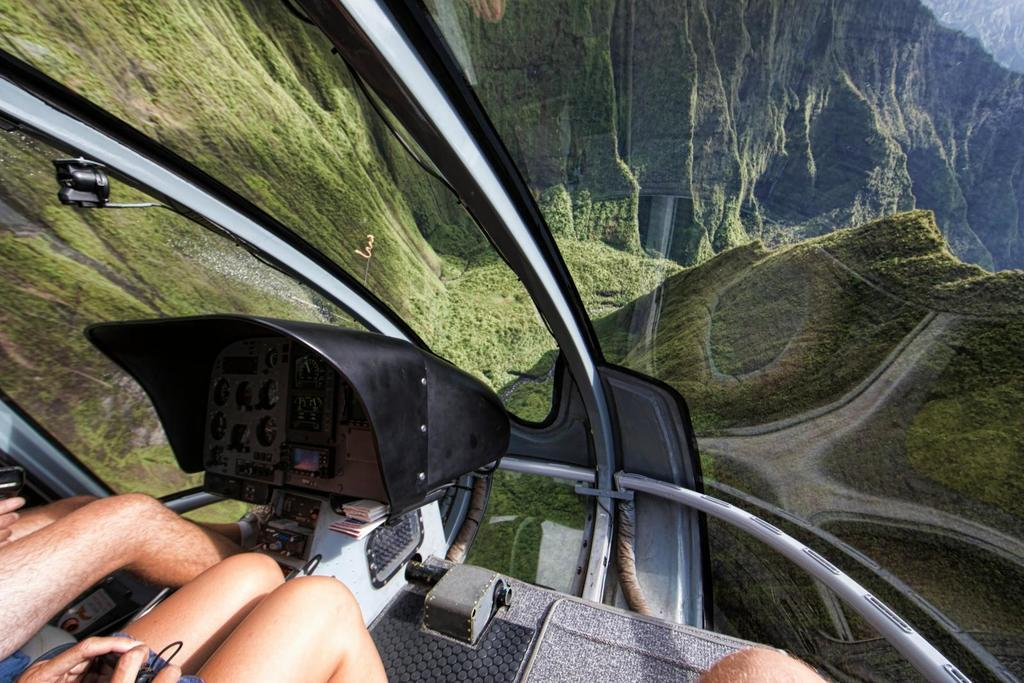What body parts are visible at the bottom of the image? Human legs are visible at the bottom of the image. What type of object is present in the image? There is a machine in the image. What is the purpose of the glass element in the image? The glass provides a view of the outside. What can be seen through the glass? Mountains with plants are visible through the glass. What type of game is being played in the image? There is no game being played in the image; it features human legs, a machine, a glass element, and a view of mountains with plants. How does the door in the image open? There is no door present in the image. 